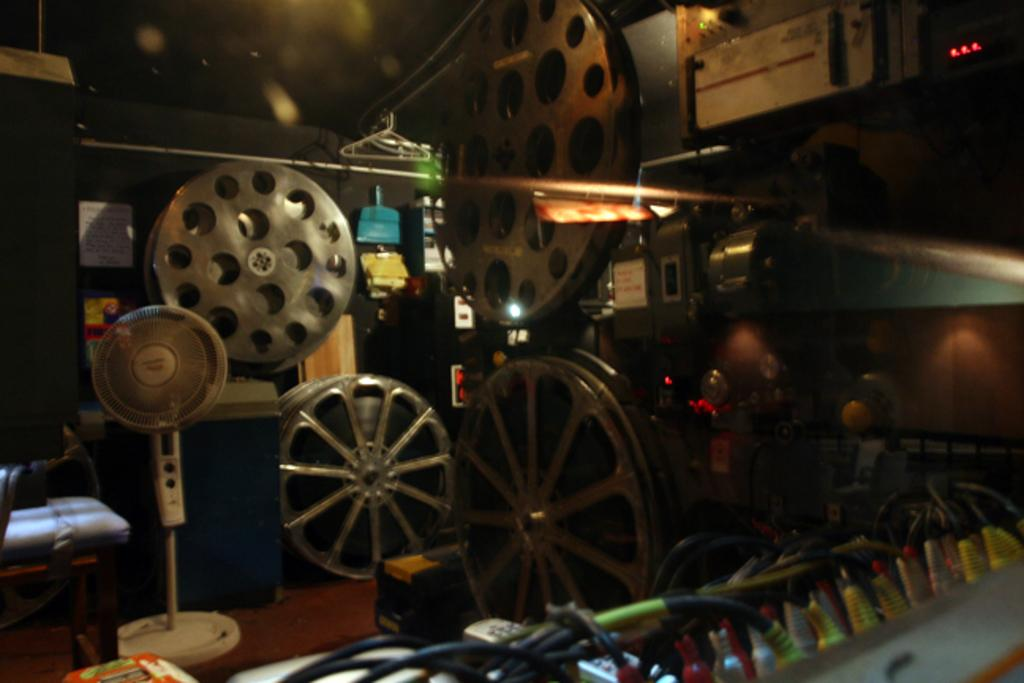What object is located on the left side of the image? There is a fan and a chair on the left side of the image. Can you describe the fan in the image? The fan is an object that provides air circulation. What else is present on the left side of the image? There is a chair on the left side of the image. What can be seen in the background of the image? There is a metal instrument visible in the background of the image. What type of notebook is being used by the patient in the hospital room? There is no patient or hospital room present in the image, and therefore no notebook can be observed. What kind of experience does the person have with the metal instrument in the image? There is no person present in the image, and the metal instrument's purpose or use cannot be determined from the image. 